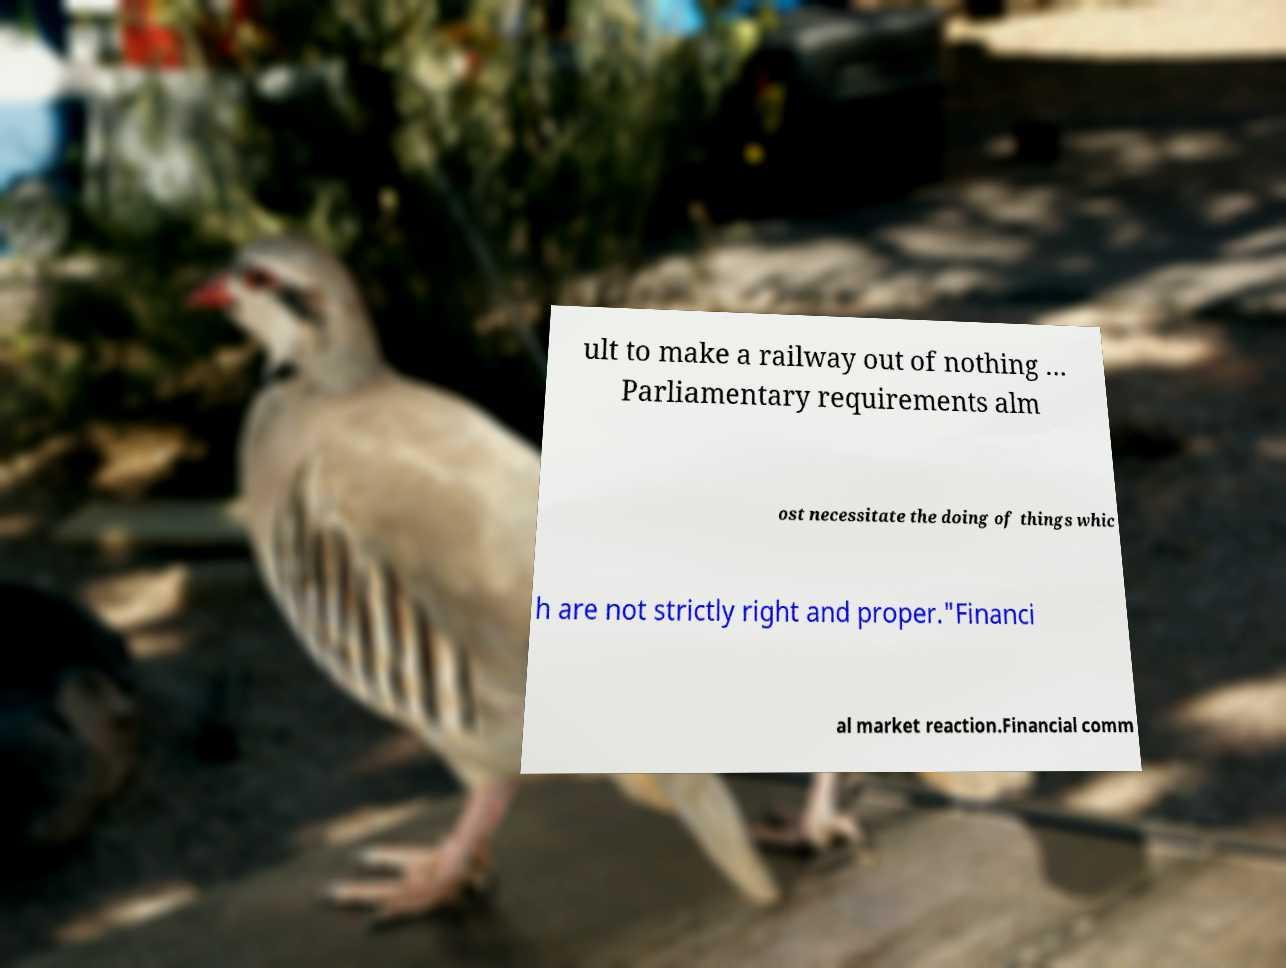Could you assist in decoding the text presented in this image and type it out clearly? ult to make a railway out of nothing … Parliamentary requirements alm ost necessitate the doing of things whic h are not strictly right and proper."Financi al market reaction.Financial comm 